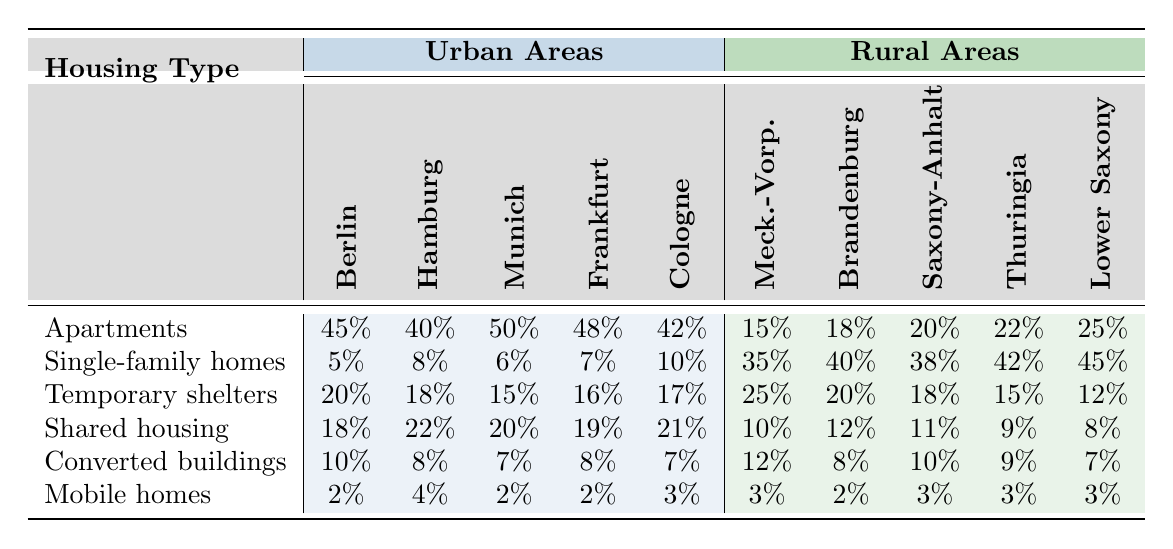What is the percentage of refugees living in apartments in Munich? In the row for 'Apartments', look under the column for 'Munich', which shows a value of 50. Therefore, the percentage of refugees living in apartments in Munich is 50%.
Answer: 50% Which housing type has the highest percentage in rural areas? By examining the rows under rural areas, 'Single-family homes' has the highest percentage at 45% in 'Lower Saxony'.
Answer: Single-family homes What is the percentage difference of refugees living in temporary shelters between Berlin and Mecklenburg-Vorpommern? In 'Temporary shelters', Berlin is 20% and Mecklenburg-Vorpommern is 25%. The difference is 25% - 20% = 5%.
Answer: 5% Is the percentage of mobile homes higher in urban or rural areas? The percentages for mobile homes in urban areas are 2%, 4%, 2%, 2%, and 3%, while in rural areas it is consistently 3%. Since 3% is greater than the highest urban percentage of 4%, mobile homes are higher in rural areas.
Answer: No What is the average percentage of shared housing across all urban areas? The percentages for shared housing in urban areas are 18%, 22%, 20%, 19%, and 21%. Adding them gives 100% and dividing by 5 (the number of urban areas) results in an average of 20%.
Answer: 20% Which rural area has the lowest percentage of apartments? Looking at the 'Apartments' row for rural areas, the lowest percentage is found in 'Mecklenburg-Vorpommern' with 15%.
Answer: Mecklenburg-Vorpommern How many rural areas have a higher percentage of single-family homes than urban areas? Comparing single-family homes, urban areas exhibit a maximum of 10% (Cologne), while all rural areas (35% to 45%) exceed this, indicating that all rural areas have higher percentages.
Answer: All rural areas What is the total percentage of refugees living in converted buildings in urban areas? The percentages for converted buildings in urban areas are 10%, 8%, 7%, 8%, and 7%. The total is 10 + 8 + 7 + 8 + 7 = 40%.
Answer: 40% What percentage of residents live in shared housing compared to apartments in Hamburg? For 'Shared housing' in Hamburg, the percentage is 22%, and for 'Apartments', it is 40%. Thus, when compared, 22% is significantly lower than 40%.
Answer: Lower Is there any area where temporary shelters exceed 20%? In the row for 'Temporary shelters', Mecklenburg-Vorpommern displays a percentage of 25%, surpassing 20%.
Answer: Yes 